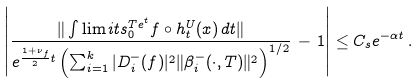<formula> <loc_0><loc_0><loc_500><loc_500>\left | \frac { \| \int \lim i t s _ { 0 } ^ { T e ^ { t } } f \circ h _ { t } ^ { U } ( x ) \, d t \| } { e ^ { \frac { 1 + \nu _ { f } } { 2 } t } \left ( \sum _ { i = 1 } ^ { k } | D ^ { - } _ { i } ( f ) | ^ { 2 } \| \beta ^ { - } _ { i } ( \cdot , T ) \| ^ { 2 } \right ) ^ { 1 / 2 } } \, - \, 1 \right | \leq C _ { s } e ^ { - \alpha t } \, .</formula> 